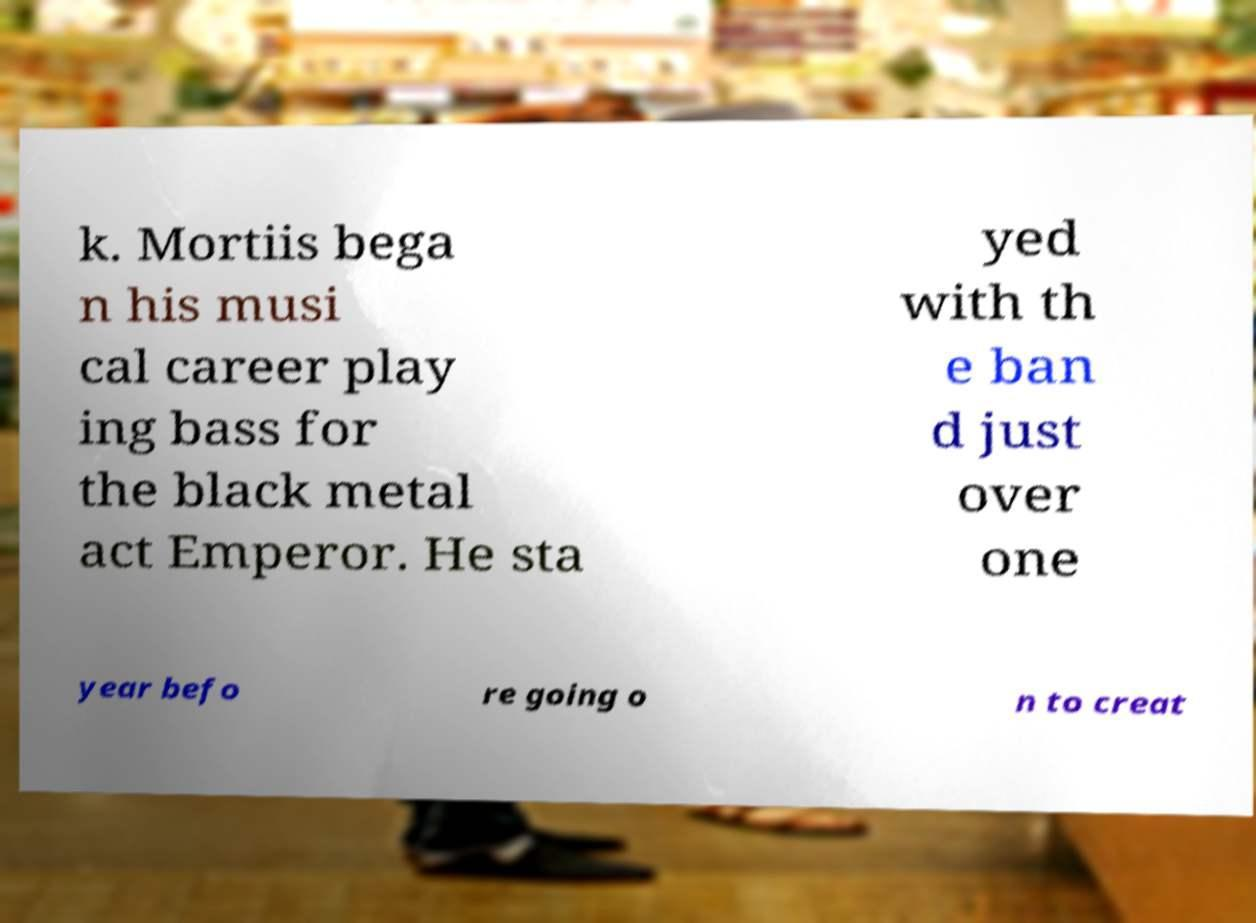For documentation purposes, I need the text within this image transcribed. Could you provide that? k. Mortiis bega n his musi cal career play ing bass for the black metal act Emperor. He sta yed with th e ban d just over one year befo re going o n to creat 